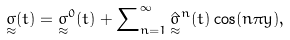Convert formula to latex. <formula><loc_0><loc_0><loc_500><loc_500>\underset { \approx } { \sigma } ( t ) = { \underset { \approx } { \sigma } ^ { 0 } } ( t ) + \sum \nolimits _ { n = 1 } ^ { \infty } { { \hat { \underset { \approx } { \sigma } } ^ { n } } } ( t ) \cos ( n \pi y ) ,</formula> 